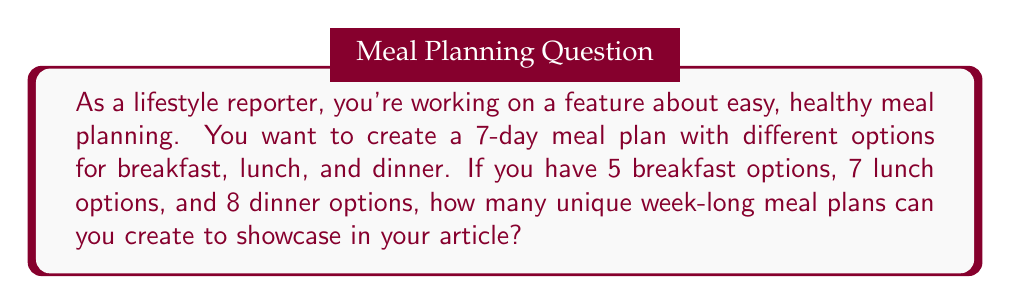Show me your answer to this math problem. Let's break this down step-by-step in a way that's accessible to our readers:

1) First, we need to understand what we're calculating. For each day, we're choosing:
   - 1 breakfast out of 5 options
   - 1 lunch out of 7 options
   - 1 dinner out of 8 options

2) For a single day, the number of possible combinations would be:
   $5 \times 7 \times 8 = 280$

3) However, we're creating a plan for 7 days, and each day can have a different combination.

4) In mathematics, when we're selecting options independently for each instance (in this case, each day), we multiply the number of possibilities.

5) So, for 7 days, we raise our single day possibilities to the power of 7:

   $$(5 \times 7 \times 8)^7$$

6) Let's break this down:
   $$280^7 = 280 \times 280 \times 280 \times 280 \times 280 \times 280 \times 280$$

7) This gives us a very large number:
   $$280^7 = 215,671,155,797,760,000$$

This means there are over 215 quadrillion possible unique week-long meal plans!

This large number showcases the incredible variety possible even with a limited number of options, which could be an interesting point for your lifestyle article.
Answer: $$215,671,155,797,760,000$$ unique week-long meal plans 